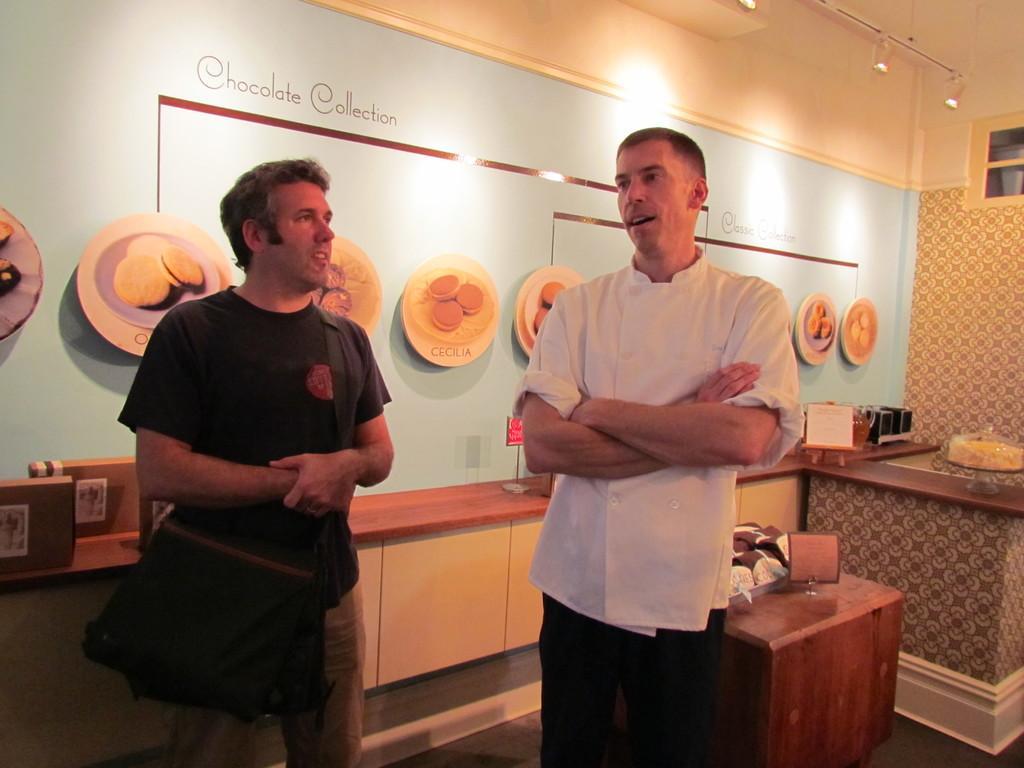In one or two sentences, can you explain what this image depicts? In this image I see 2 men and in the background and there are few things on it and I see the wall and the lights. 